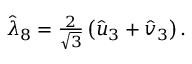<formula> <loc_0><loc_0><loc_500><loc_500>\begin{array} { r } { \hat { \lambda } _ { 8 } = \frac { 2 } { \sqrt { 3 } } \left ( \hat { u } _ { 3 } + \hat { v } _ { 3 } \right ) . } \end{array}</formula> 